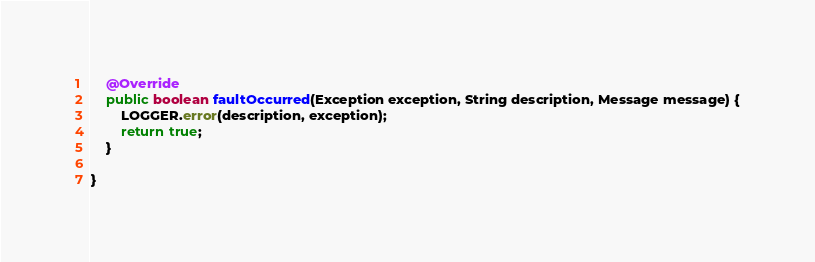Convert code to text. <code><loc_0><loc_0><loc_500><loc_500><_Java_>    @Override
    public boolean faultOccurred(Exception exception, String description, Message message) {
        LOGGER.error(description, exception);
        return true;
    }

}
</code> 